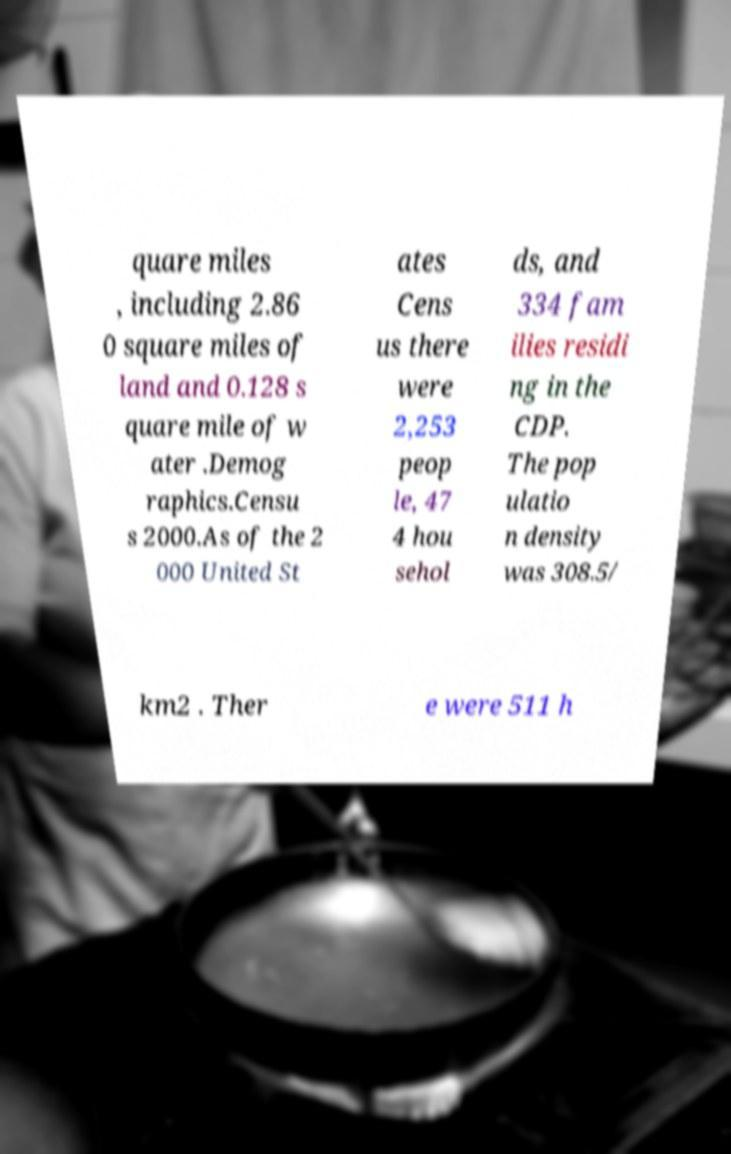Can you read and provide the text displayed in the image?This photo seems to have some interesting text. Can you extract and type it out for me? quare miles , including 2.86 0 square miles of land and 0.128 s quare mile of w ater .Demog raphics.Censu s 2000.As of the 2 000 United St ates Cens us there were 2,253 peop le, 47 4 hou sehol ds, and 334 fam ilies residi ng in the CDP. The pop ulatio n density was 308.5/ km2 . Ther e were 511 h 